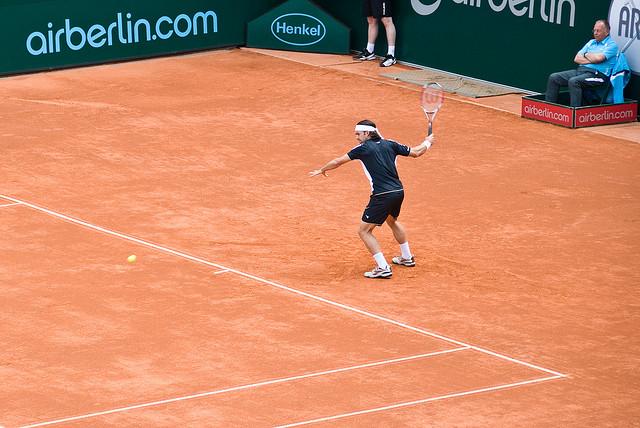Will the player be able to return the ball?
Quick response, please. Yes. Is the ball moving upwards or downwards?
Concise answer only. Downwards. Which hand does this man write with?
Concise answer only. Right. 